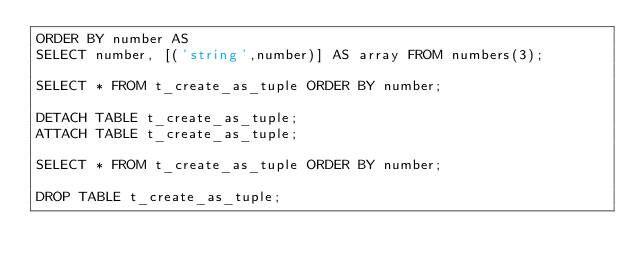<code> <loc_0><loc_0><loc_500><loc_500><_SQL_>ORDER BY number AS
SELECT number, [('string',number)] AS array FROM numbers(3);

SELECT * FROM t_create_as_tuple ORDER BY number;

DETACH TABLE t_create_as_tuple;
ATTACH TABLE t_create_as_tuple;

SELECT * FROM t_create_as_tuple ORDER BY number;

DROP TABLE t_create_as_tuple;
</code> 